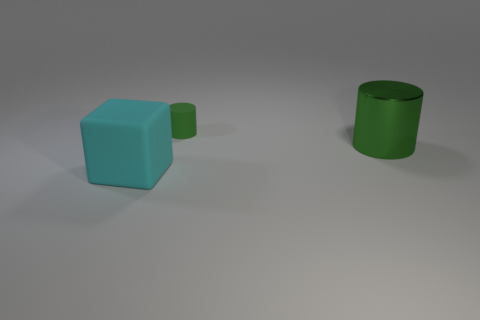Can you describe the lighting and shadows present in this image? The image features soft and diffuse lighting, casting gentle shadows beneath each object. This suggests an even and non-directional light source, possibly simulating an overcast sky or indoor ambient lighting. 